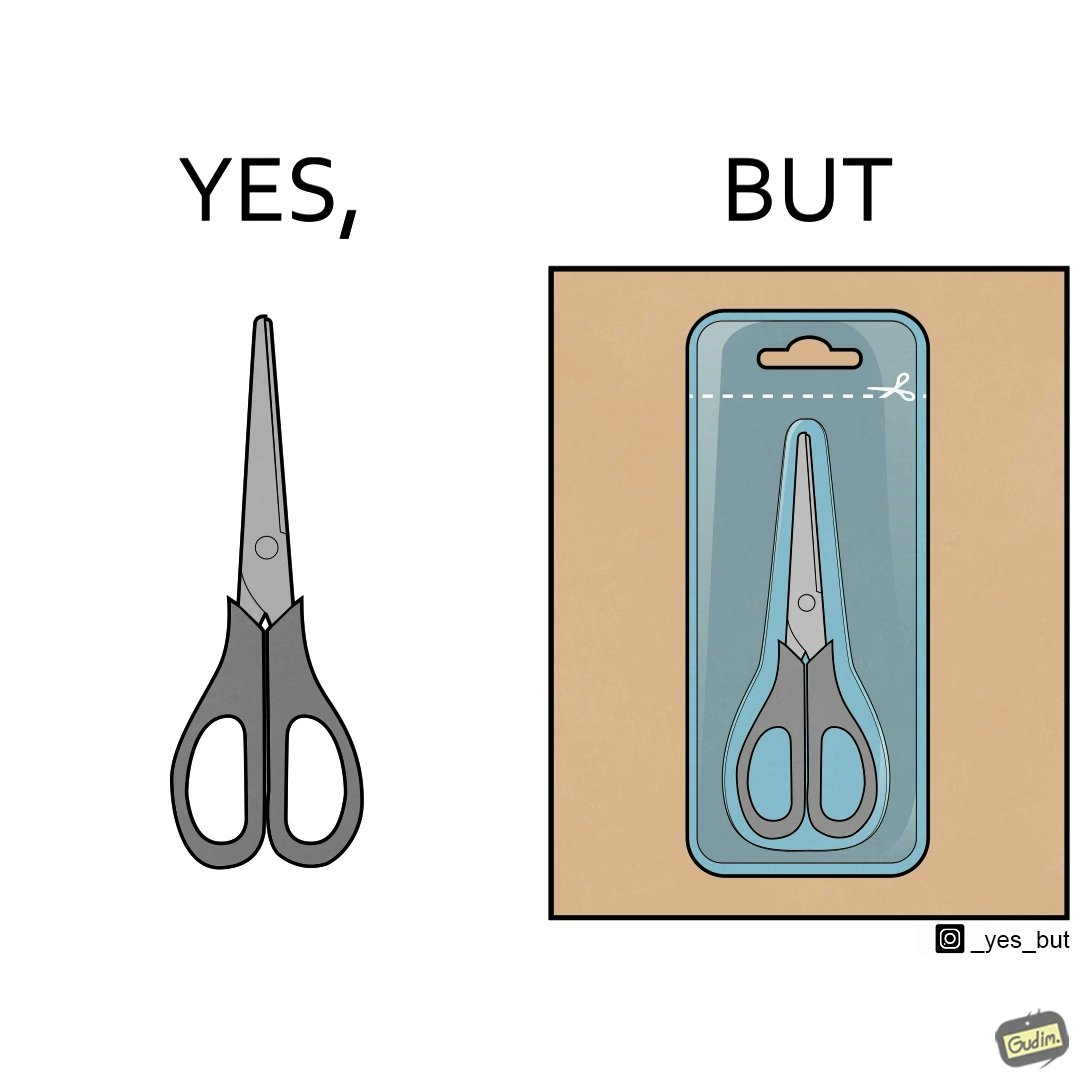Compare the left and right sides of this image. In the left part of the image: a pair of scissors In the right part of the image: a pair of scissors inside a packaging, with a marking at the top showing that you would need to open it using a pair of scissors. 